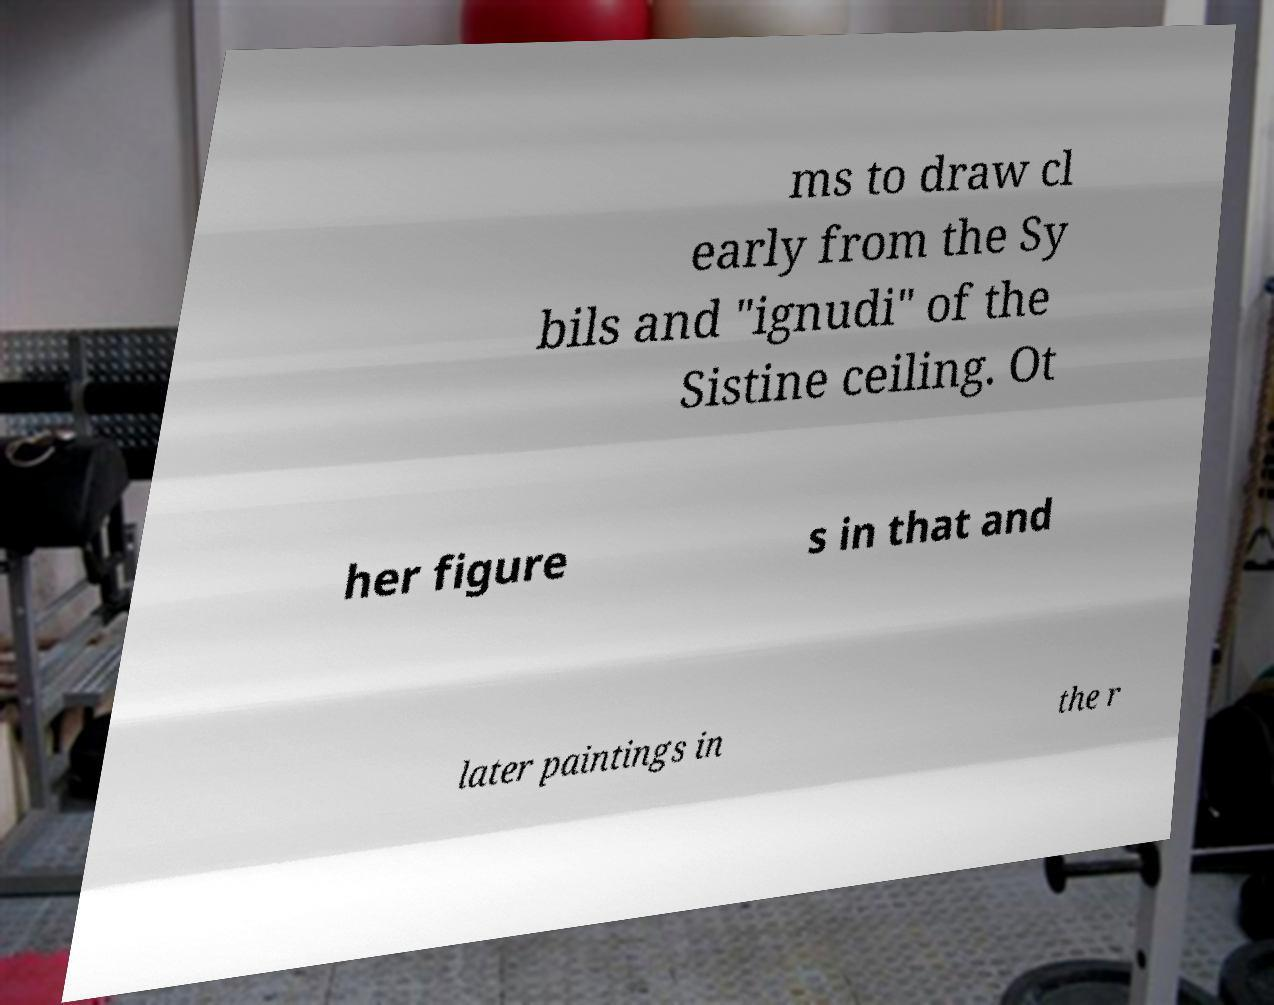What messages or text are displayed in this image? I need them in a readable, typed format. ms to draw cl early from the Sy bils and "ignudi" of the Sistine ceiling. Ot her figure s in that and later paintings in the r 